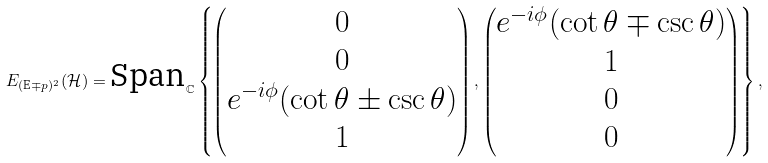<formula> <loc_0><loc_0><loc_500><loc_500>E _ { ( \text {E} \mp p ) ^ { 2 } } ( \mathcal { H } ) = \text {Span} _ { \mathbb { C } } \left \{ \begin{pmatrix} 0 \\ 0 \\ e ^ { - i \phi } ( \cot \theta \pm \csc \theta ) \\ 1 \end{pmatrix} , \begin{pmatrix} e ^ { - i \phi } ( \cot \theta \mp \csc \theta ) \\ 1 \\ 0 \\ 0 \end{pmatrix} \right \} ,</formula> 